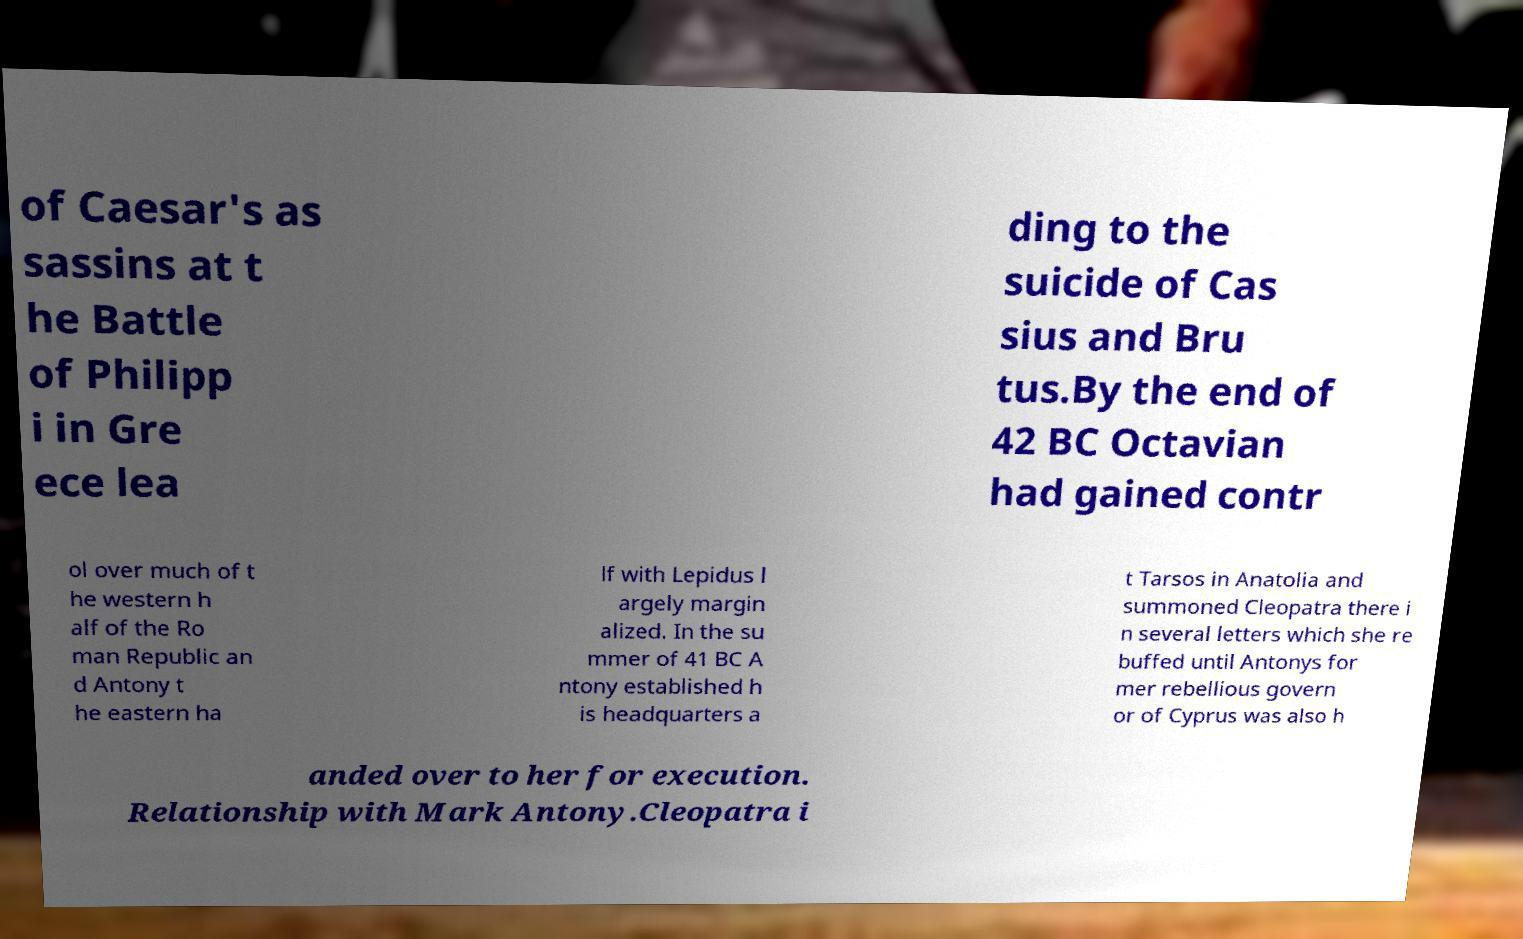What messages or text are displayed in this image? I need them in a readable, typed format. of Caesar's as sassins at t he Battle of Philipp i in Gre ece lea ding to the suicide of Cas sius and Bru tus.By the end of 42 BC Octavian had gained contr ol over much of t he western h alf of the Ro man Republic an d Antony t he eastern ha lf with Lepidus l argely margin alized. In the su mmer of 41 BC A ntony established h is headquarters a t Tarsos in Anatolia and summoned Cleopatra there i n several letters which she re buffed until Antonys for mer rebellious govern or of Cyprus was also h anded over to her for execution. Relationship with Mark Antony.Cleopatra i 